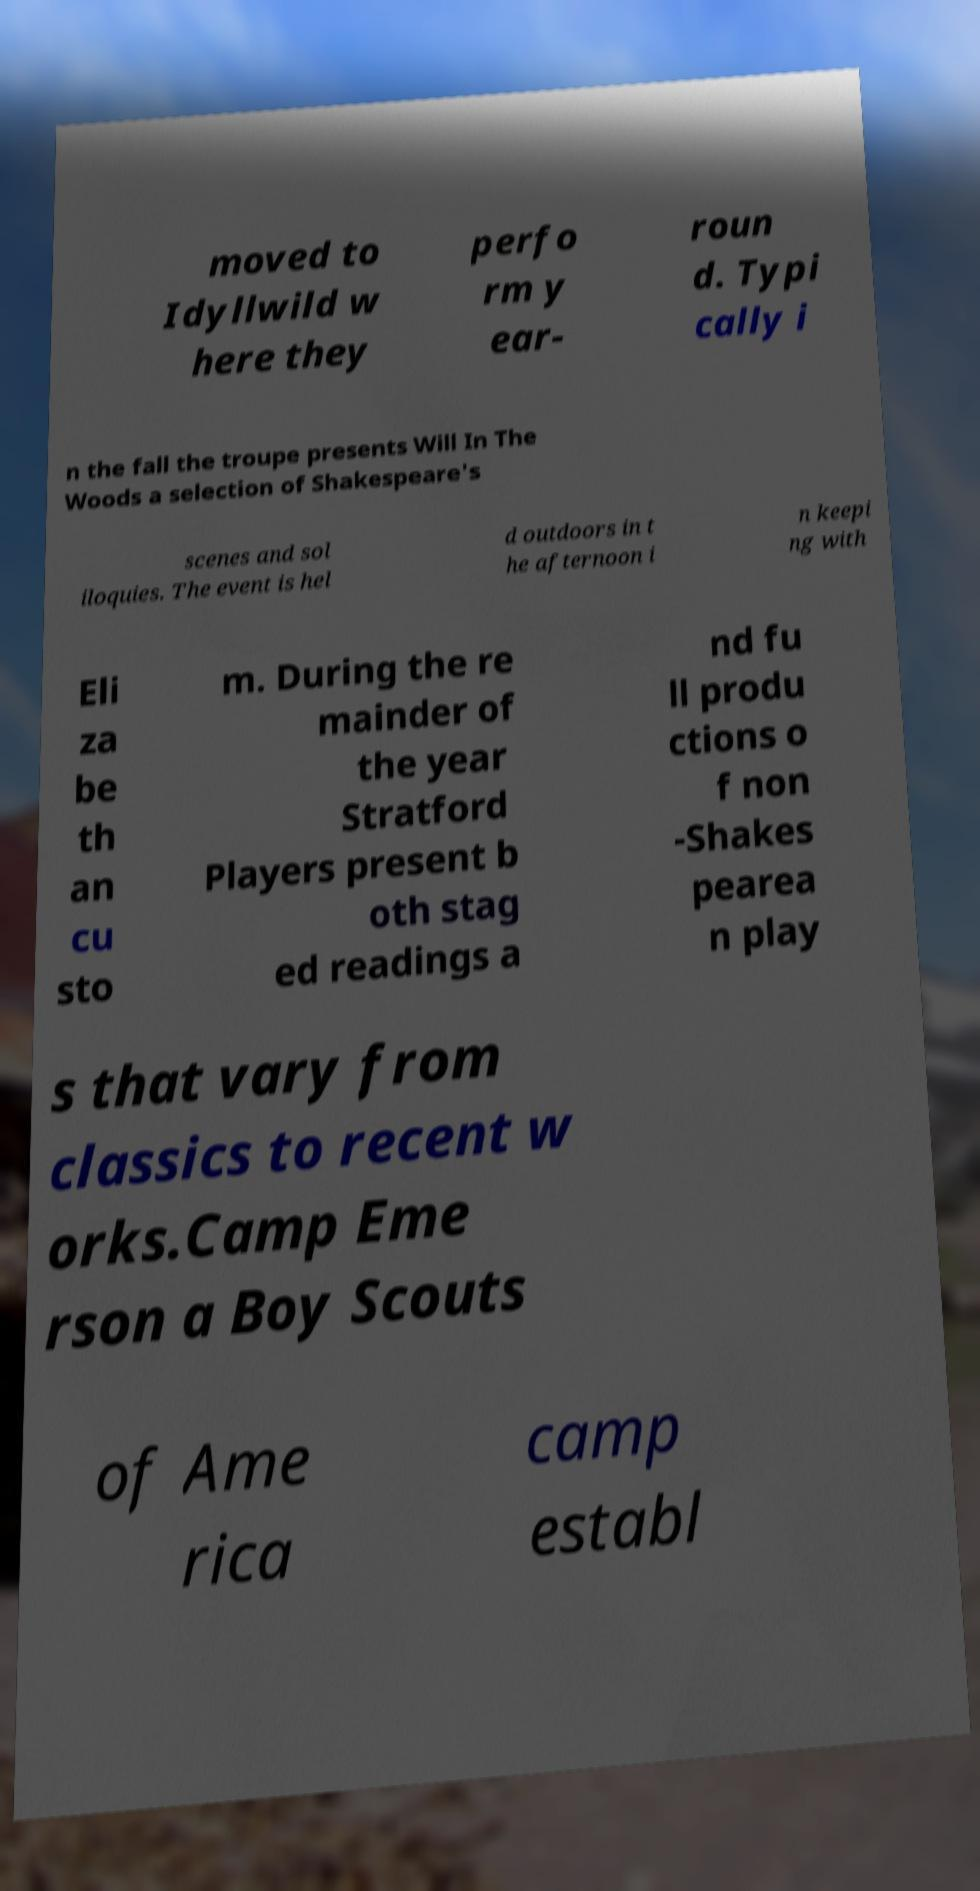Can you read and provide the text displayed in the image?This photo seems to have some interesting text. Can you extract and type it out for me? moved to Idyllwild w here they perfo rm y ear- roun d. Typi cally i n the fall the troupe presents Will In The Woods a selection of Shakespeare's scenes and sol iloquies. The event is hel d outdoors in t he afternoon i n keepi ng with Eli za be th an cu sto m. During the re mainder of the year Stratford Players present b oth stag ed readings a nd fu ll produ ctions o f non -Shakes pearea n play s that vary from classics to recent w orks.Camp Eme rson a Boy Scouts of Ame rica camp establ 